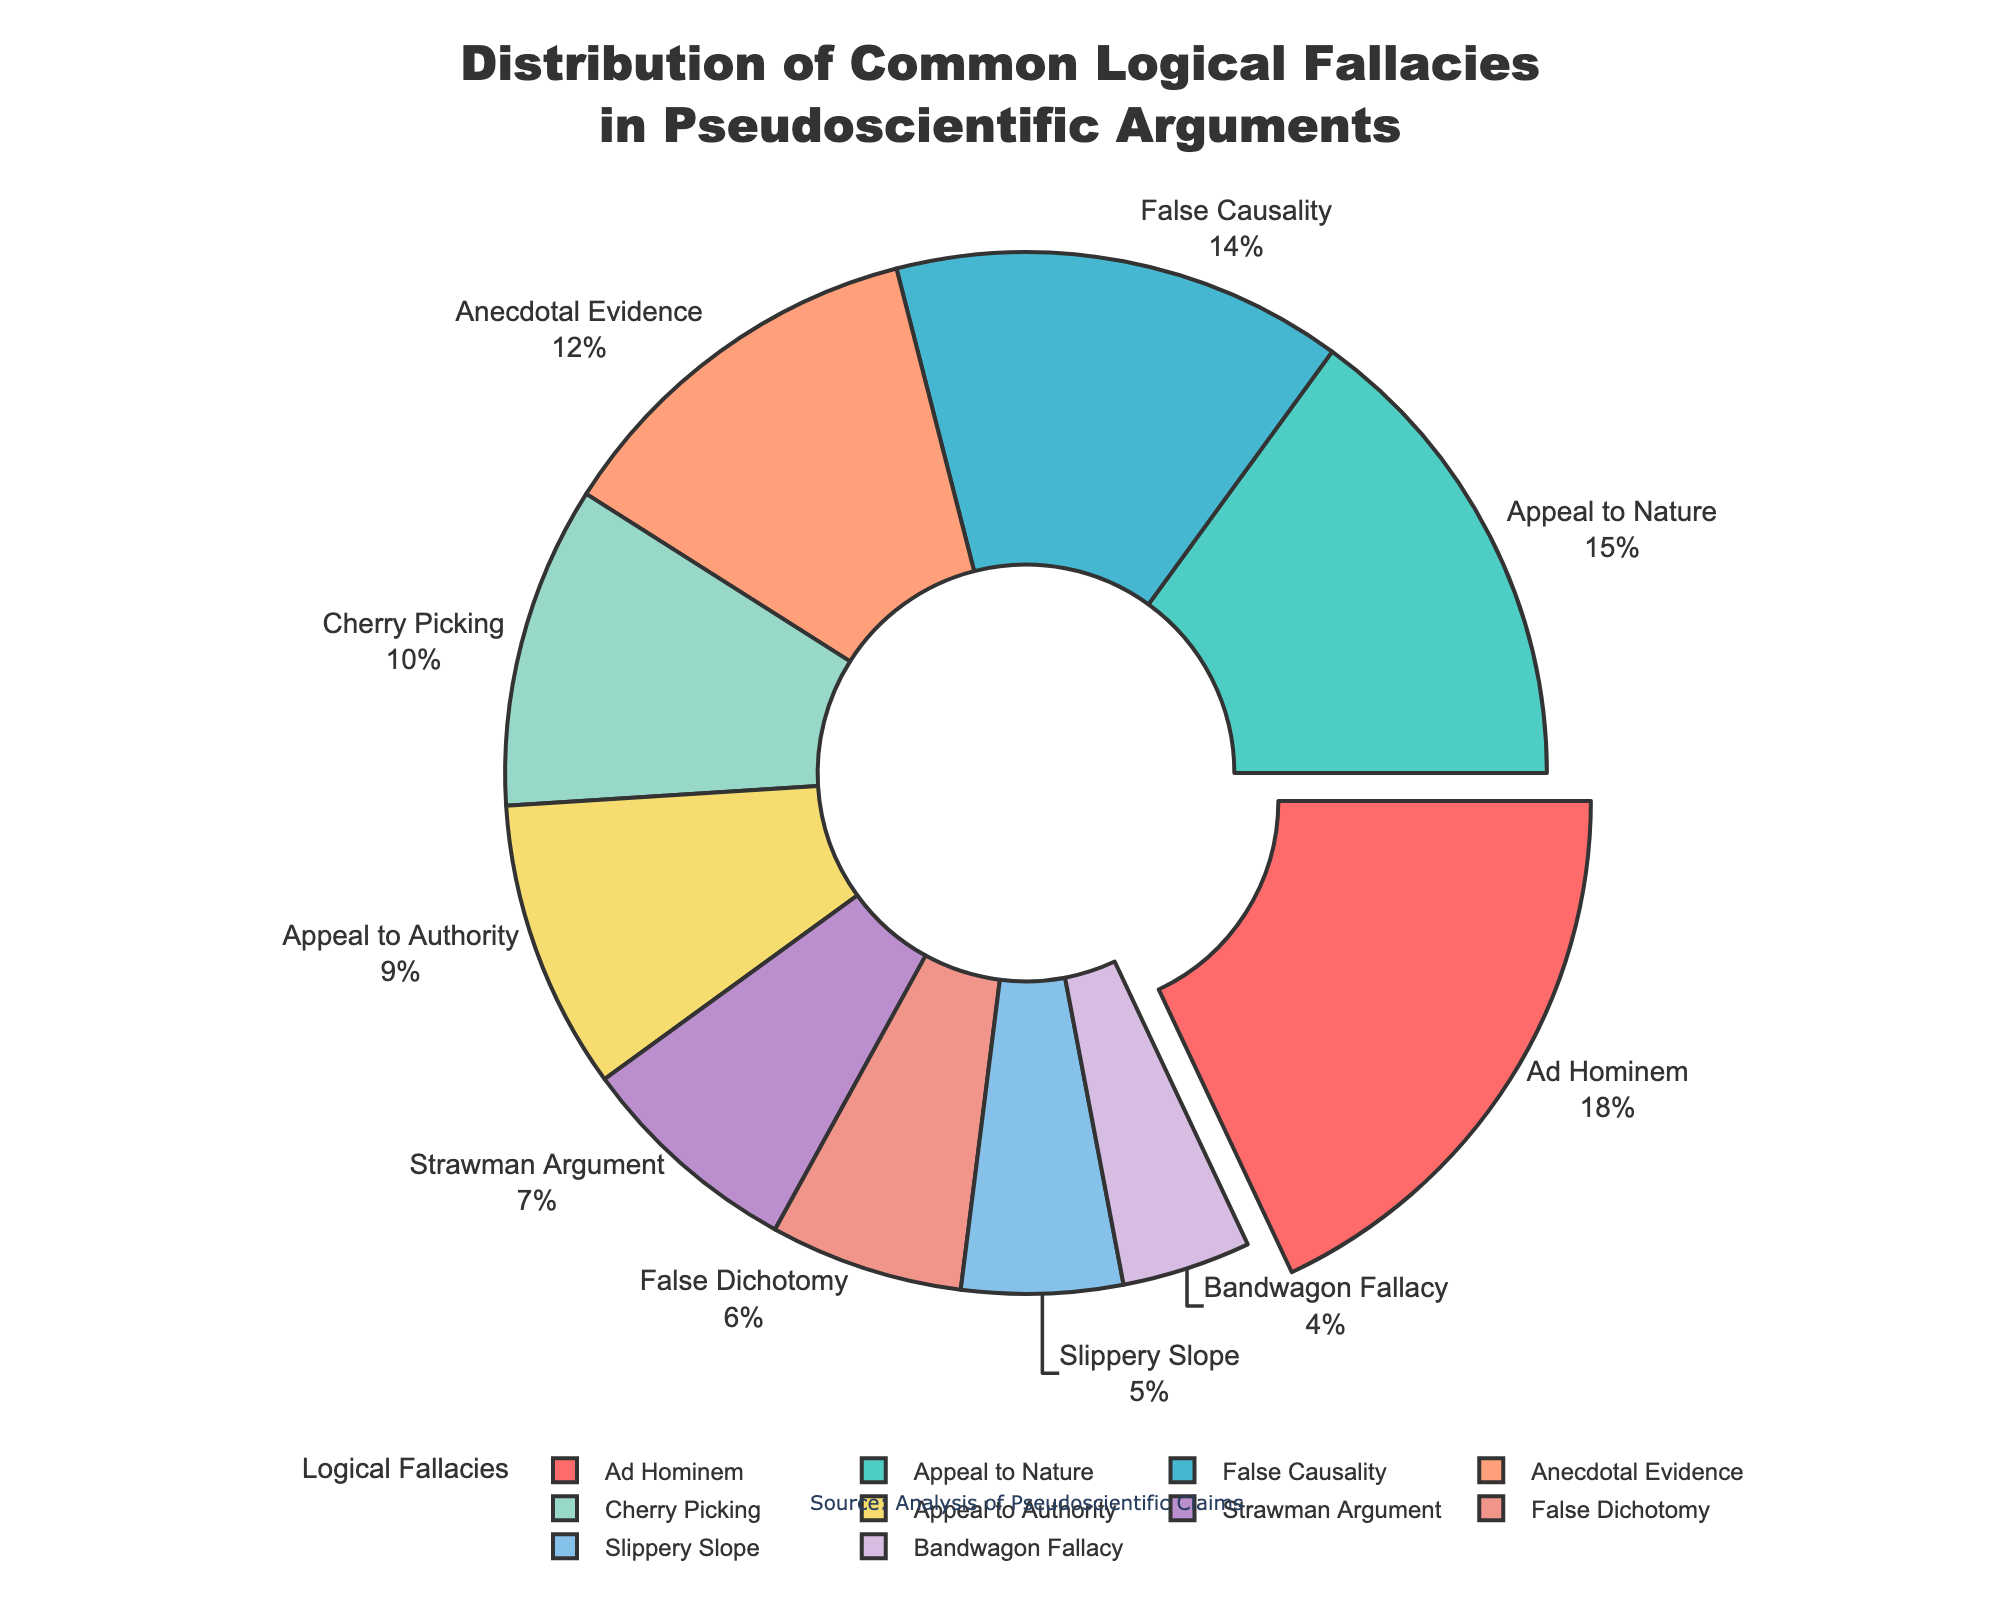Which logical fallacy has the highest percentage in pseudoscientific arguments? The figure highlights the segment with the highest percentage by pulling it out slightly. According to the pie chart, the logical fallacy with the highest percentage is "Ad Hominem" at 18%.
Answer: Ad Hominem Which two logical fallacies combined make up more than a quarter of the distribution? Adding the percentages of logical fallacies, "Ad Hominem" (18%) and "Appeal to Nature" (15%), we have 18% + 15% = 33%, which is more than a quarter (25%).
Answer: Ad Hominem and Appeal to Nature How does the percentage of "Strawman Argument" compare to "False Dichotomy"? The percentages are provided in the pie chart. "Strawman Argument" is at 7%, while "False Dichotomy" is at 6%. Therefore, "Strawman Argument" has 1% more than "False Dichotomy".
Answer: 1% more What is the combined percentage of the least common three logical fallacies? The least common three logical fallacies are "Bandwagon Fallacy" (4%), "Slippery Slope" (5%), and "False Dichotomy" (6%). Adding them together, 4% + 5% + 6% = 15%.
Answer: 15% Which color represents the "False Causality" logical fallacy? The figure uses a unique color for each segment. The segment labeled "False Causality" can be identified by its color. According to the legend, "False Causality" is represented by a shade of blue.
Answer: Blue What is the difference in percentage between "Anecdotal Evidence" and "Cherry Picking"? The pie chart indicates that "Anecdotal Evidence" stands at 12% and "Cherry Picking" at 10%. Subtracting these values gives us 12% - 10% = 2%.
Answer: 2% Which logical fallacy's percentage is exactly one-third of the percentage of "Ad Hominem"? "Ad Hominem" has a percentage of 18%. One-third of this percentage is 18% / 3 = 6%. The logical fallacy with a percentage of 6% is "False Dichotomy".
Answer: False Dichotomy How much higher is "Appeal to Authority" compared to "Bandwagon Fallacy"? According to the pie chart, "Appeal to Authority" is at 9% and "Bandwagon Fallacy" is at 4%. The difference is 9% - 4% = 5%.
Answer: 5% Which logical fallacy is represented by the green segment? Identifying the green segment on the pie chart and matching it with the corresponding label shows that the green segment represents "Appeal to Nature".
Answer: Appeal to Nature If we combine the percentages of "Slippery Slope" and "Cherry Picking", would they surpass "Ad Hominem"? "Slippery Slope" is 5% and "Cherry Picking" is 10%. Adding these gives 5% + 10% = 15%, which is less than the 18% of "Ad Hominem". Hence, they do not surpass it.
Answer: No 